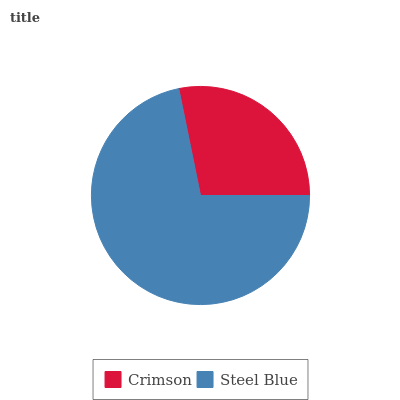Is Crimson the minimum?
Answer yes or no. Yes. Is Steel Blue the maximum?
Answer yes or no. Yes. Is Steel Blue the minimum?
Answer yes or no. No. Is Steel Blue greater than Crimson?
Answer yes or no. Yes. Is Crimson less than Steel Blue?
Answer yes or no. Yes. Is Crimson greater than Steel Blue?
Answer yes or no. No. Is Steel Blue less than Crimson?
Answer yes or no. No. Is Steel Blue the high median?
Answer yes or no. Yes. Is Crimson the low median?
Answer yes or no. Yes. Is Crimson the high median?
Answer yes or no. No. Is Steel Blue the low median?
Answer yes or no. No. 